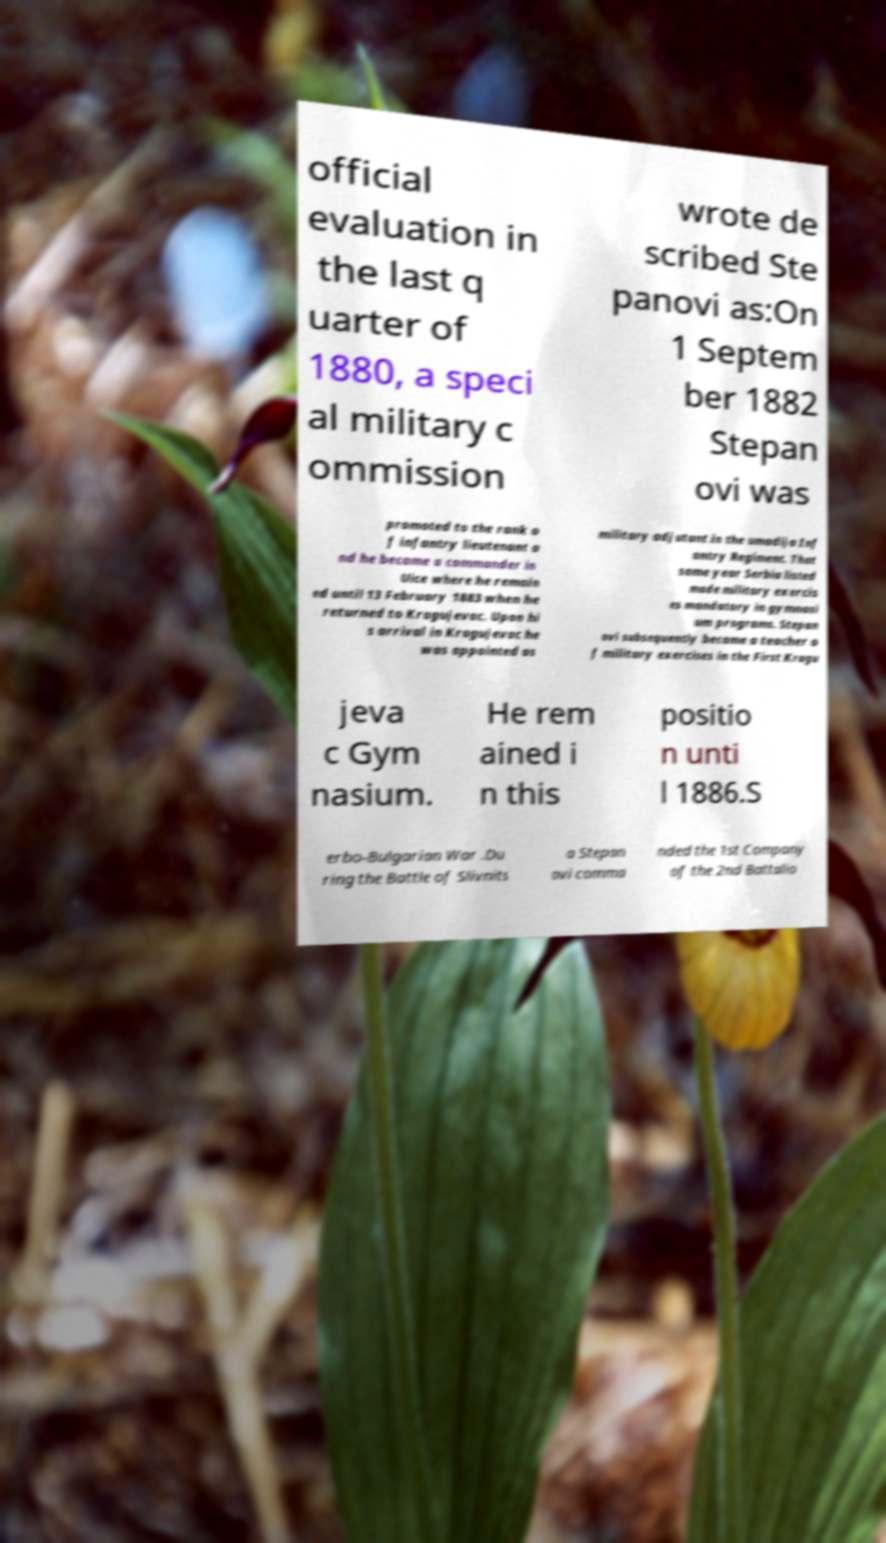Please identify and transcribe the text found in this image. official evaluation in the last q uarter of 1880, a speci al military c ommission wrote de scribed Ste panovi as:On 1 Septem ber 1882 Stepan ovi was promoted to the rank o f infantry lieutenant a nd he became a commander in Uice where he remain ed until 13 February 1883 when he returned to Kragujevac. Upon hi s arrival in Kragujevac he was appointed as military adjutant in the umadija Inf antry Regiment. That same year Serbia listed made military exercis es mandatory in gymnasi um programs. Stepan ovi subsequently became a teacher o f military exercises in the First Kragu jeva c Gym nasium. He rem ained i n this positio n unti l 1886.S erbo-Bulgarian War .Du ring the Battle of Slivnits a Stepan ovi comma nded the 1st Company of the 2nd Battalio 